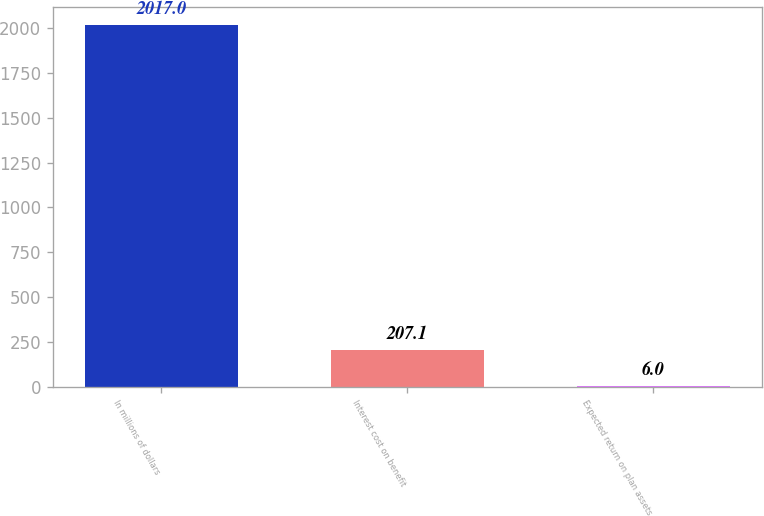Convert chart. <chart><loc_0><loc_0><loc_500><loc_500><bar_chart><fcel>In millions of dollars<fcel>Interest cost on benefit<fcel>Expected return on plan assets<nl><fcel>2017<fcel>207.1<fcel>6<nl></chart> 